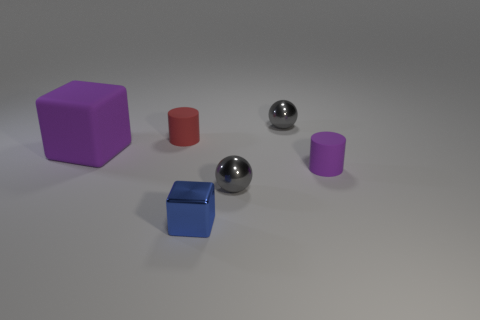Add 2 large metallic blocks. How many objects exist? 8 Subtract all cubes. How many objects are left? 4 Add 6 tiny gray metal spheres. How many tiny gray metal spheres are left? 8 Add 2 purple matte things. How many purple matte things exist? 4 Subtract 0 gray blocks. How many objects are left? 6 Subtract all tiny red matte cylinders. Subtract all metallic balls. How many objects are left? 3 